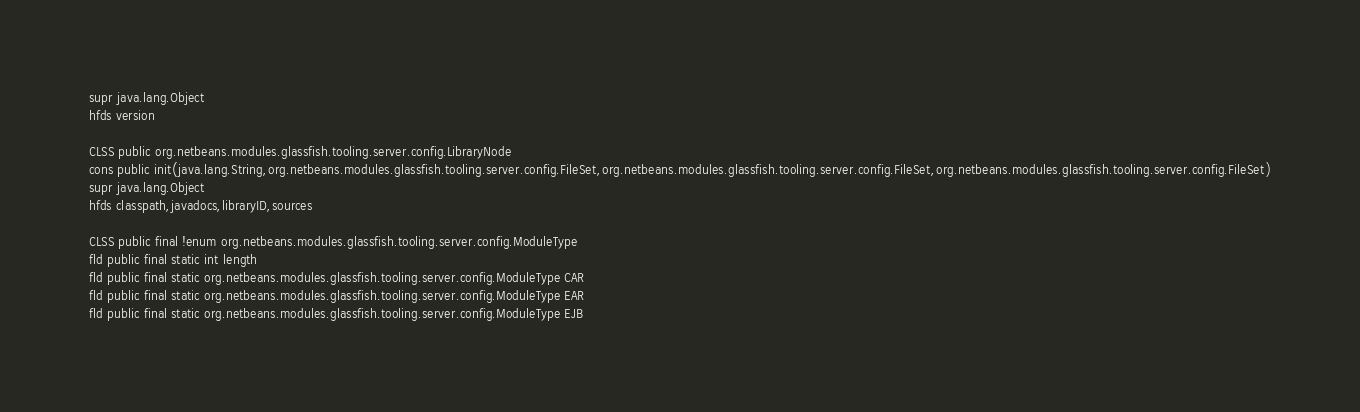<code> <loc_0><loc_0><loc_500><loc_500><_SML_>supr java.lang.Object
hfds version

CLSS public org.netbeans.modules.glassfish.tooling.server.config.LibraryNode
cons public init(java.lang.String,org.netbeans.modules.glassfish.tooling.server.config.FileSet,org.netbeans.modules.glassfish.tooling.server.config.FileSet,org.netbeans.modules.glassfish.tooling.server.config.FileSet)
supr java.lang.Object
hfds classpath,javadocs,libraryID,sources

CLSS public final !enum org.netbeans.modules.glassfish.tooling.server.config.ModuleType
fld public final static int length
fld public final static org.netbeans.modules.glassfish.tooling.server.config.ModuleType CAR
fld public final static org.netbeans.modules.glassfish.tooling.server.config.ModuleType EAR
fld public final static org.netbeans.modules.glassfish.tooling.server.config.ModuleType EJB</code> 